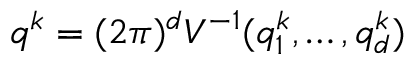Convert formula to latex. <formula><loc_0><loc_0><loc_500><loc_500>q ^ { k } = { ( 2 \pi ) ^ { d } } V ^ { - 1 } ( q _ { 1 } ^ { k } , \dots , q _ { d } ^ { k } )</formula> 